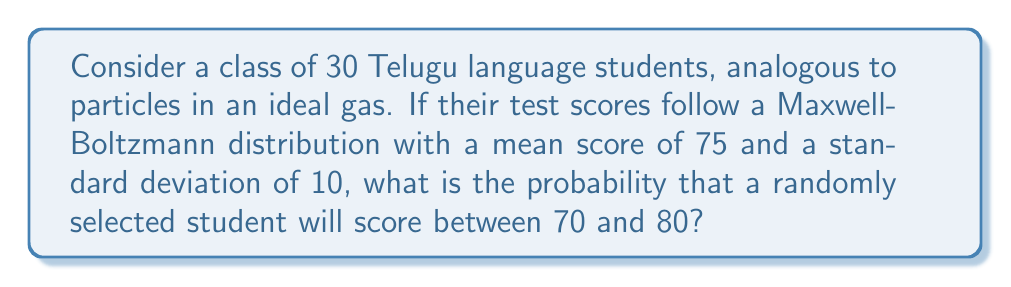Can you solve this math problem? To solve this problem, we'll use the properties of the Maxwell-Boltzmann distribution and apply it to our analogy of test scores. Let's proceed step-by-step:

1) The Maxwell-Boltzmann distribution for an ideal gas is given by:

   $$f(v) = 4\pi \left(\frac{m}{2\pi kT}\right)^{3/2} v^2 e^{-mv^2/2kT}$$

   In our analogy, we'll treat the test scores as velocities.

2) For a normal distribution (which the Maxwell-Boltzmann distribution approximates for a single component), we can use the standard normal distribution (z-score) to calculate probabilities.

3) The z-score formula is:

   $$z = \frac{x - \mu}{\sigma}$$

   where $x$ is the score, $\mu$ is the mean, and $\sigma$ is the standard deviation.

4) For the lower bound (70):
   
   $$z_1 = \frac{70 - 75}{10} = -0.5$$

5) For the upper bound (80):
   
   $$z_2 = \frac{80 - 75}{10} = 0.5$$

6) The probability is the area under the standard normal curve between these two z-scores. We can find this using a standard normal table or a calculator.

7) The probability is:

   $$P(-0.5 < Z < 0.5) = P(Z < 0.5) - P(Z < -0.5)$$

8) Using a standard normal table:

   $$P(Z < 0.5) \approx 0.6915$$
   $$P(Z < -0.5) \approx 0.3085$$

9) Therefore, the probability is:

   $$0.6915 - 0.3085 = 0.3830$$
Answer: 0.3830 or approximately 38.30% 